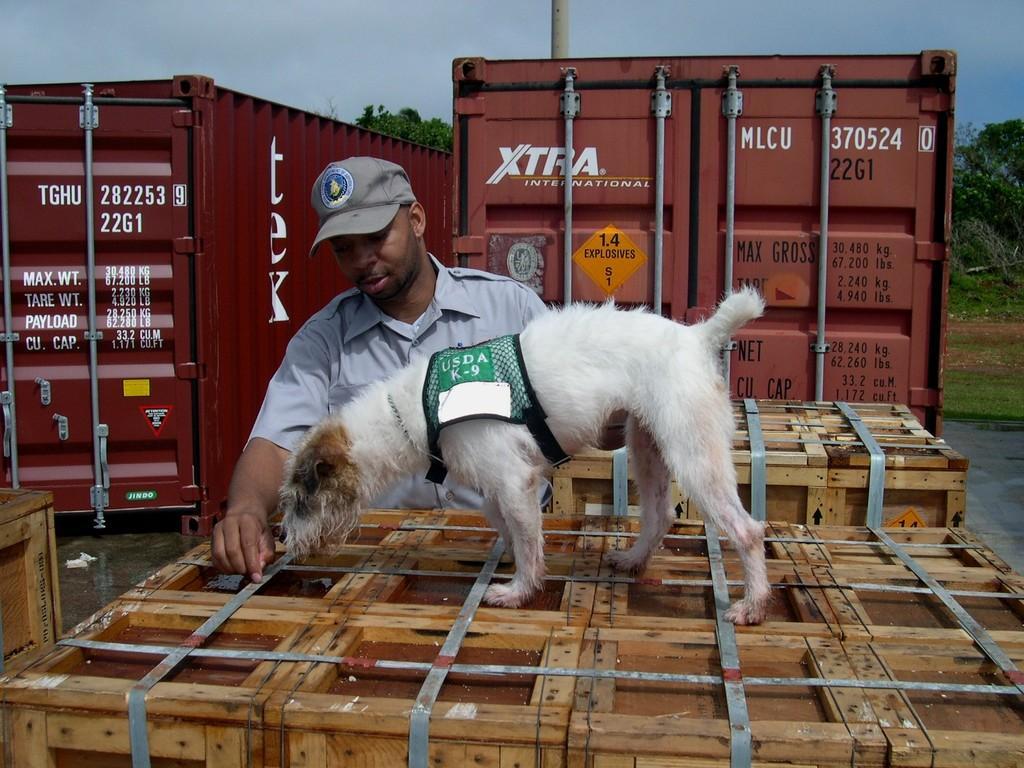Describe this image in one or two sentences. In this picture we can see a person and a dog, here we can see wooden objects on the ground and in the background we can see containers, trees, pole, sky. 